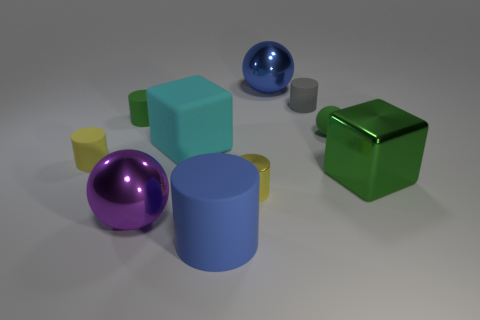Can you tell me the colors of the spherical objects in the scene and their sizes relative to each other? Certainly! In the scene, there are two spherical objects: one is purple and the other is blue. The purple sphere appears to be slightly larger than the blue sphere when comparing their sizes relative to each other. 